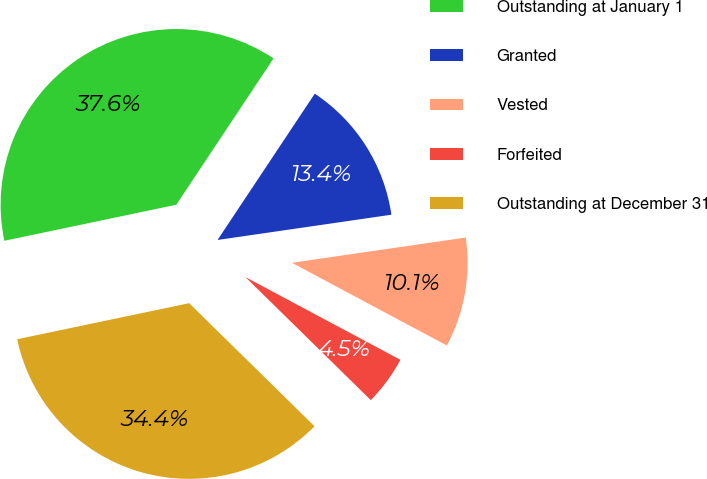Convert chart. <chart><loc_0><loc_0><loc_500><loc_500><pie_chart><fcel>Outstanding at January 1<fcel>Granted<fcel>Vested<fcel>Forfeited<fcel>Outstanding at December 31<nl><fcel>37.63%<fcel>13.37%<fcel>10.1%<fcel>4.55%<fcel>34.36%<nl></chart> 